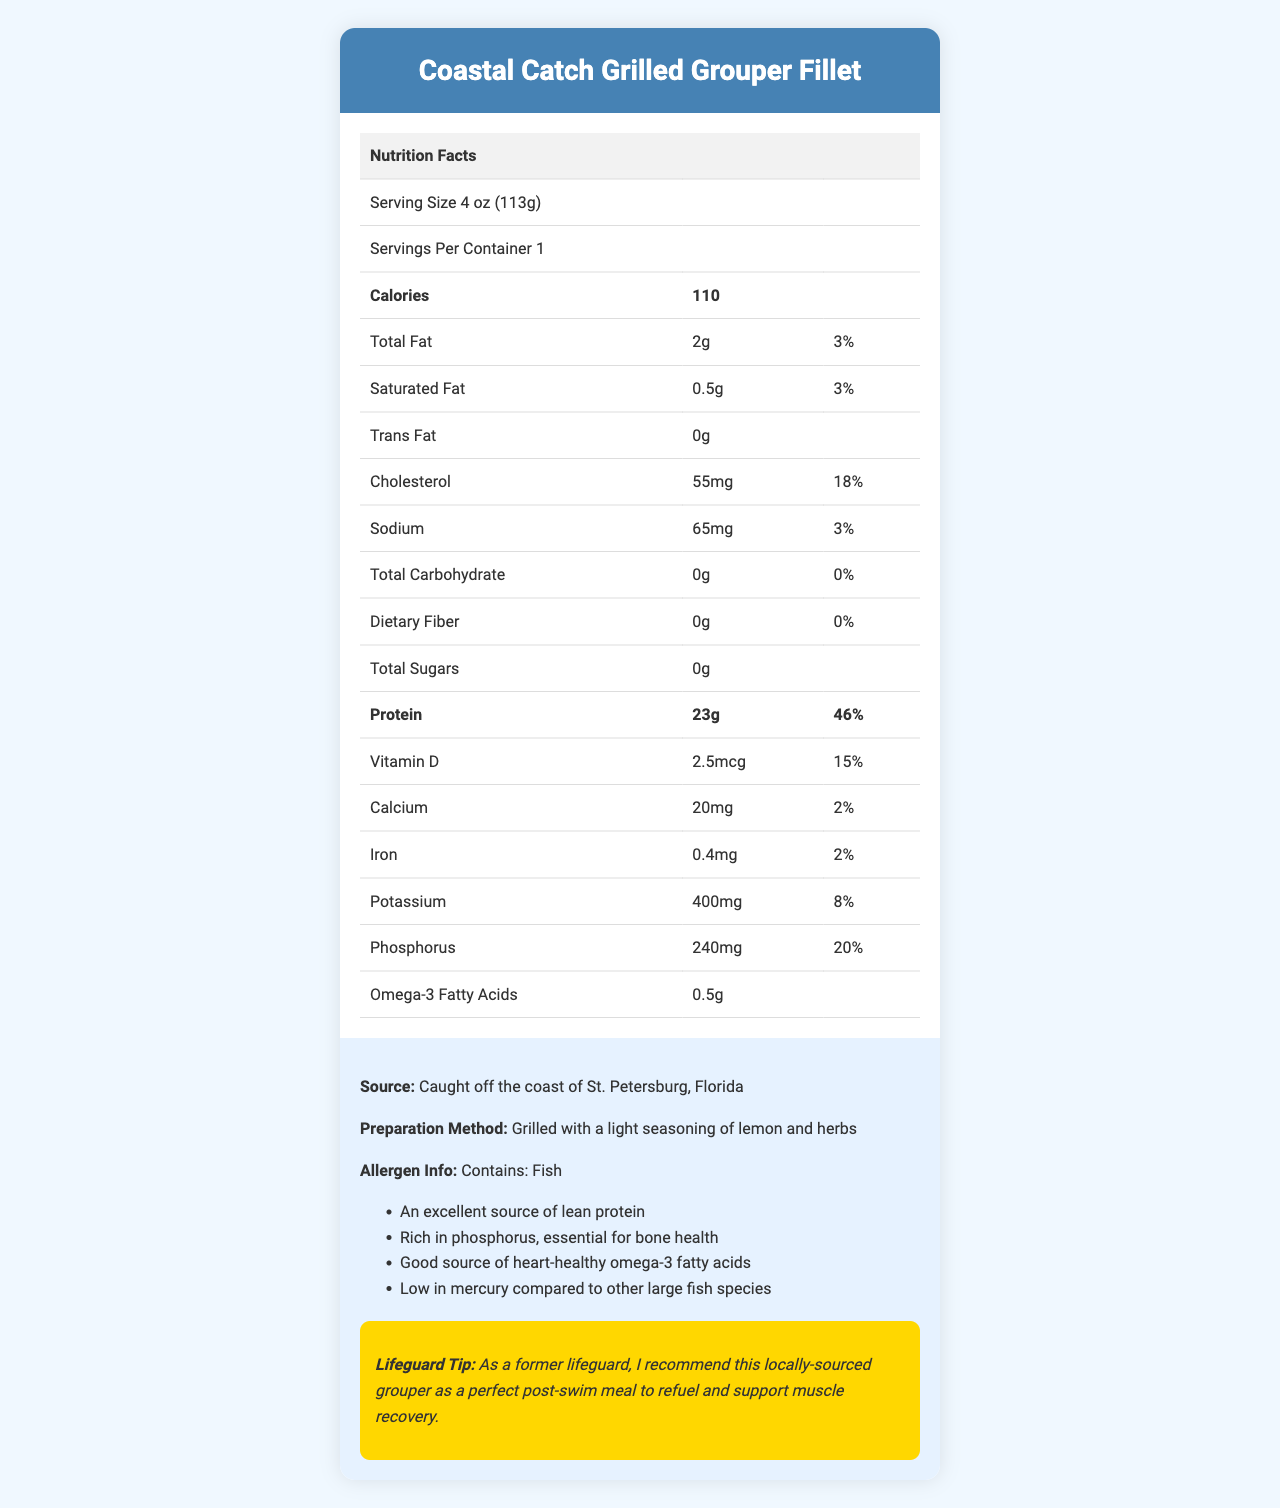what is the serving size? The serving size is listed as "4 oz (113g)" in the document.
Answer: 4 oz (113g) how many calories are in one serving? The document states that there are 110 calories per serving.
Answer: 110 how much protein is in the grouper fillet? The protein amount is specified as "23g" in the nutrition facts table.
Answer: 23g where is the grouper sourced from? The source of the grouper is listed in the additional information section.
Answer: Caught off the coast of St. Petersburg, Florida what percentage of the daily value of sodium does this fillet provide? The sodium section of the nutrition facts lists "3%" as the percentage of the daily value.
Answer: 3% how is the grouper fillet prepared? The preparation method is mentioned under additional information.
Answer: Grilled with a light seasoning of lemon and herbs how much phosphorus does this fillet contain? The nutrition facts table lists the phosphorus content as "240mg".
Answer: 240mg does the grouper fillet contain any dietary fiber? The dietary fiber amount is listed as "0g" in the document.
Answer: No how much vitamin D is in the grouper fillet? The vitamin D content is specified as "2.5mcg" in the nutrition facts.
Answer: 2.5mcg what is the daily value percentage for cholesterol in this fillet? A. 18% B. 3% C. 20% The daily value percentage for cholesterol is listed as "18%" in the nutrition facts.
Answer: A. 18% how much omega-3 fatty acids are in the fillet? A. 0g B. 0.5g C. 1g D. 2g The omega-3 fatty acids content is specified as "0.5g".
Answer: B. 0.5g is the nutrient profile of this grouper fillet considered lean? The additional info indicates that it is "An excellent source of lean protein".
Answer: Yes does this fillet contain any allergens? The allergen info states "Contains: Fish".
Answer: Yes summarize the document's main idea. The document comprehensively covers the nutritional content, origin, preparation, and health benefits of a locally sourced grilled grouper fillet.
Answer: This document provides the nutrition facts for the Coastal Catch Grilled Grouper Fillet, highlighting its lean protein profile and additional nutritional benefits. It details the serving size, calories, various nutrients, preparation method, and allergen information. Also, it mentions that the fish is locally sourced from St. Petersburg, Florida, and includes a lifeguard tip about its suitability as a post-swim meal for muscle recovery. what is the detailed nutrient breakdown for potassium? The potassium content is given as "400mg" and the daily value percentage as "8%" in the nutrition facts.
Answer: 400mg, 8% what is the recommended post-swim meal according to the lifeguard tip? The lifeguard tip explicitly recommends the Coastal Catch Grilled Grouper Fillet as a perfect post-swim meal.
Answer: Coastal Catch Grilled Grouper Fillet what is the iron content in the fillet? The nutrition facts table states that the iron content is "0.4mg".
Answer: 0.4mg how much total carbohydrate is there in the grouper fillet? A. 0g B. 10g C. 20g The total carbohydrate amount is listed as "0g" in the document.
Answer: A. 0g what is the source of the ingredients of this fillet? The document specifies the source of the grouper but does not provide detailed information on the origin of the ingredients used for seasoning.
Answer: Cannot be determined 